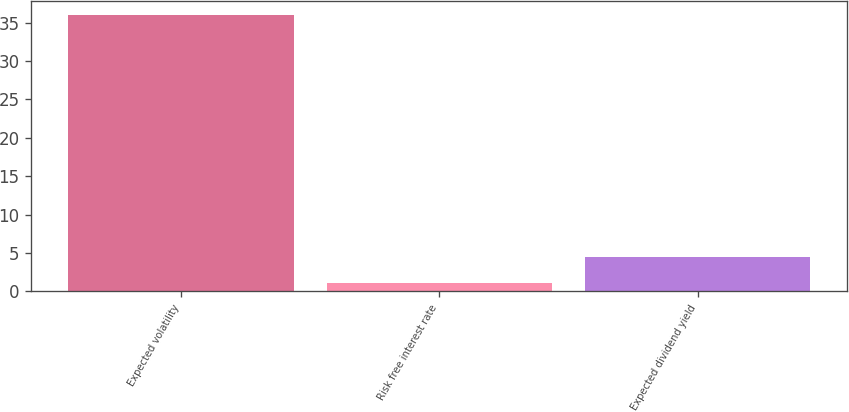Convert chart. <chart><loc_0><loc_0><loc_500><loc_500><bar_chart><fcel>Expected volatility<fcel>Risk free interest rate<fcel>Expected dividend yield<nl><fcel>36<fcel>1.05<fcel>4.55<nl></chart> 